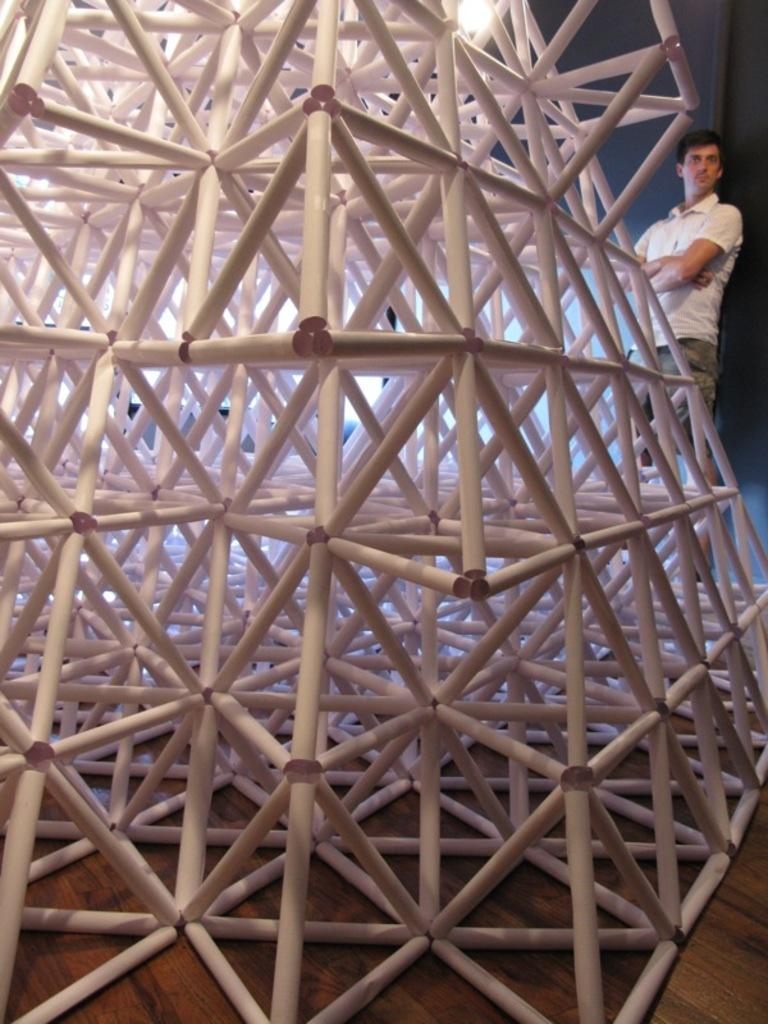What type of material is used to construct the tower in the image? The tower in the image is made with timber. Can you describe the person in the image? There is a person standing at the back of the image. What is the surface at the bottom of the image? There is a wooden floor at the bottom of the image. How does the person in the image care for the detail in the wooden floor? There is no indication in the image that the person is caring for the detail in the wooden floor, as the person's actions are not described. 